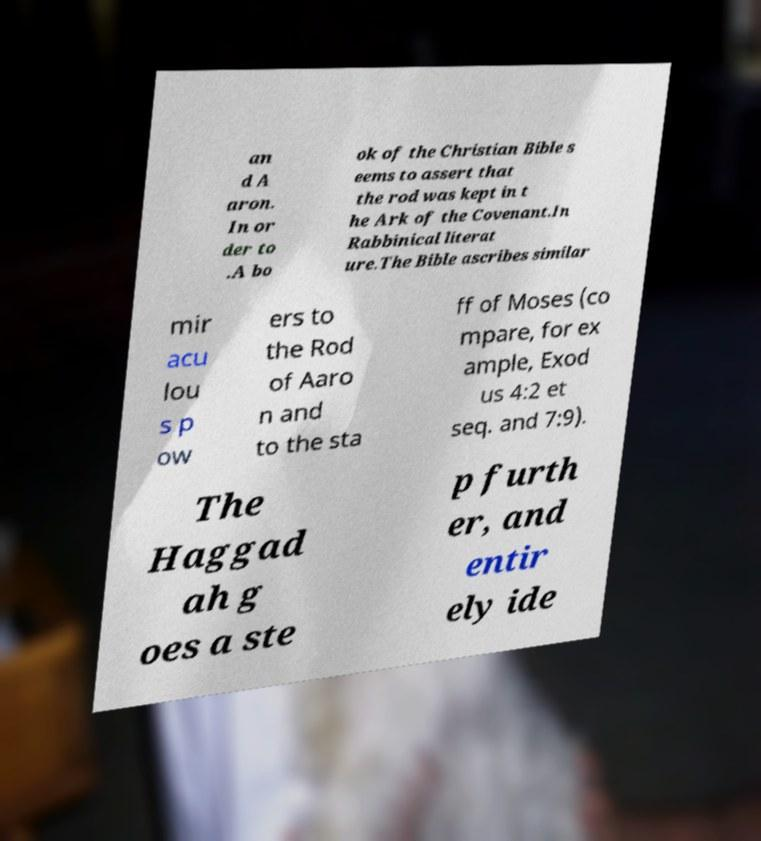Could you assist in decoding the text presented in this image and type it out clearly? an d A aron. In or der to .A bo ok of the Christian Bible s eems to assert that the rod was kept in t he Ark of the Covenant.In Rabbinical literat ure.The Bible ascribes similar mir acu lou s p ow ers to the Rod of Aaro n and to the sta ff of Moses (co mpare, for ex ample, Exod us 4:2 et seq. and 7:9). The Haggad ah g oes a ste p furth er, and entir ely ide 